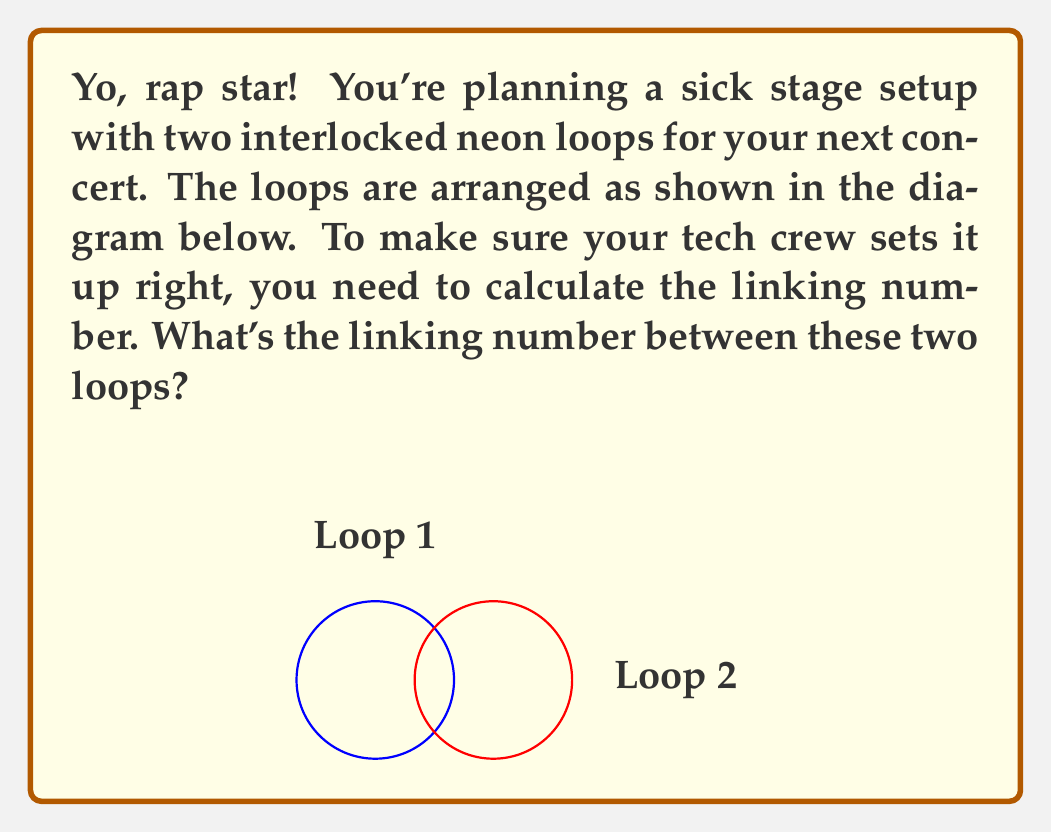Could you help me with this problem? Alright, let's break this down step-by-step, just like you break down your rhymes:

1) The linking number is a topological invariant that measures how two closed curves are linked in three-dimensional space.

2) To compute the linking number, we need to:
   a) Choose an orientation for each loop
   b) Count the number of crossings
   c) Assign +1 or -1 to each crossing based on its type
   d) Sum these values and divide by 2

3) Let's orient Loop 1 counterclockwise and Loop 2 from left to right.

4) In the given diagram, we can see two crossings where Loop 2 passes over Loop 1.

5) To determine the type of crossing:
   - Imagine standing on Loop 1, facing the direction of its orientation
   - If Loop 2 crosses from left to right, it's a +1 crossing
   - If Loop 2 crosses from right to left, it's a -1 crossing

6) In this case:
   - The left crossing: Loop 2 goes from left to right (+1)
   - The right crossing: Loop 2 goes from right to left (-1)

7) Sum of crossings: (+1) + (-1) = 0

8) Linking number = Sum of crossings / 2 = 0 / 2 = 0

Therefore, the linking number between these two loops is 0.
Answer: 0 